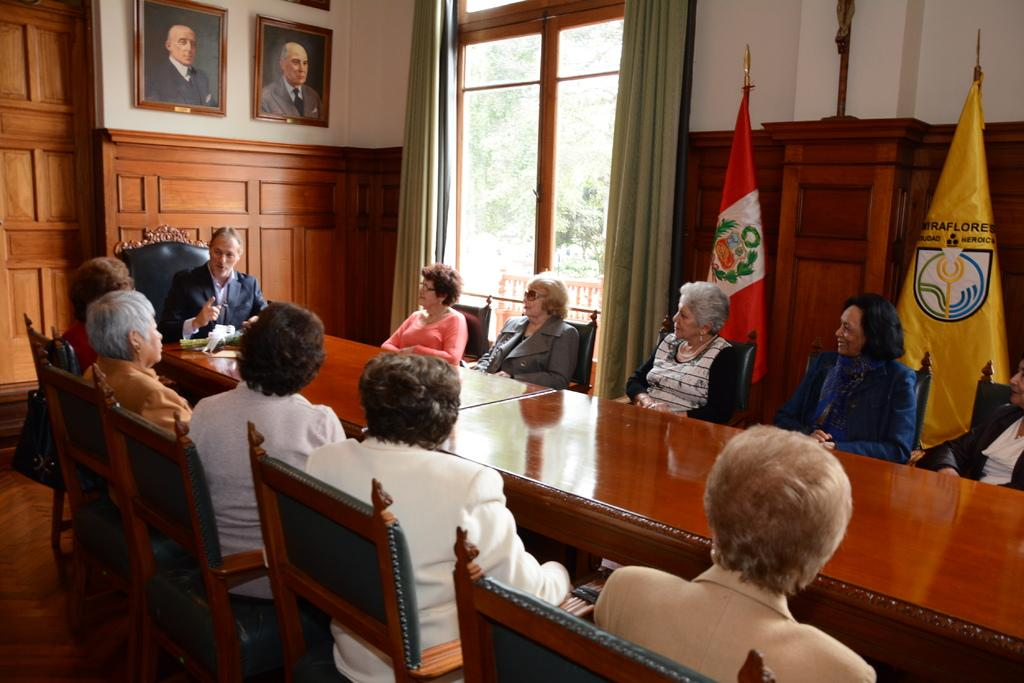What type of structure can be seen in the image? There is a wall in the image. What is hanging on the wall? There is a photo frame in the image. What can be seen in the background of the image? There is a window in the image. What is flying in the image? There is a flag in the image. What are the people in the image doing? There are people sitting on chairs in the image. What piece of furniture is present in the image? There is a table in the image. What type of bread can be seen on the table in the image? There is no bread present in the image; it only features a table, chairs, and people sitting on them. Can you tell me how many airplanes are flying in the image? There are no airplanes present in the image; it only features a flag flying in the background. 